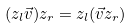Convert formula to latex. <formula><loc_0><loc_0><loc_500><loc_500>( z _ { l } \vec { v } ) z _ { r } = z _ { l } ( \vec { v } z _ { r } )</formula> 